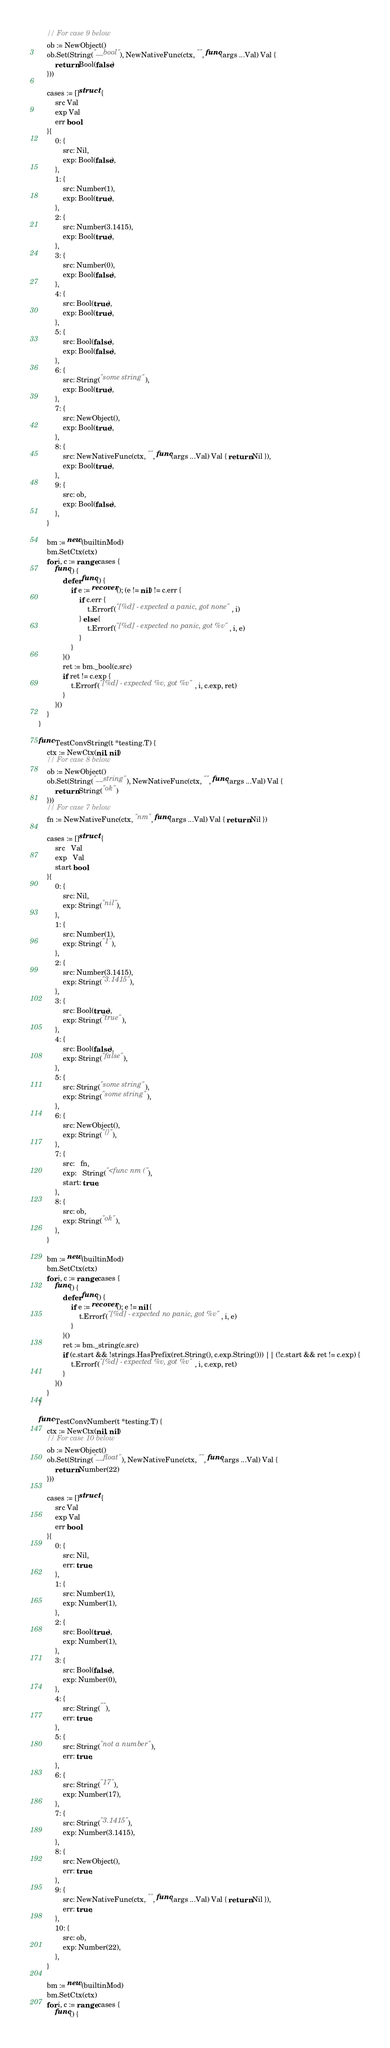Convert code to text. <code><loc_0><loc_0><loc_500><loc_500><_Go_>	// For case 9 below
	ob := NewObject()
	ob.Set(String("__bool"), NewNativeFunc(ctx, "", func(args ...Val) Val {
		return Bool(false)
	}))

	cases := []struct {
		src Val
		exp Val
		err bool
	}{
		0: {
			src: Nil,
			exp: Bool(false),
		},
		1: {
			src: Number(1),
			exp: Bool(true),
		},
		2: {
			src: Number(3.1415),
			exp: Bool(true),
		},
		3: {
			src: Number(0),
			exp: Bool(false),
		},
		4: {
			src: Bool(true),
			exp: Bool(true),
		},
		5: {
			src: Bool(false),
			exp: Bool(false),
		},
		6: {
			src: String("some string"),
			exp: Bool(true),
		},
		7: {
			src: NewObject(),
			exp: Bool(true),
		},
		8: {
			src: NewNativeFunc(ctx, "", func(args ...Val) Val { return Nil }),
			exp: Bool(true),
		},
		9: {
			src: ob,
			exp: Bool(false),
		},
	}

	bm := new(builtinMod)
	bm.SetCtx(ctx)
	for i, c := range cases {
		func() {
			defer func() {
				if e := recover(); (e != nil) != c.err {
					if c.err {
						t.Errorf("[%d] - expected a panic, got none", i)
					} else {
						t.Errorf("[%d] - expected no panic, got %v", i, e)
					}
				}
			}()
			ret := bm._bool(c.src)
			if ret != c.exp {
				t.Errorf("[%d] - expected %v, got %v", i, c.exp, ret)
			}
		}()
	}
}

func TestConvString(t *testing.T) {
	ctx := NewCtx(nil, nil)
	// For case 8 below
	ob := NewObject()
	ob.Set(String("__string"), NewNativeFunc(ctx, "", func(args ...Val) Val {
		return String("ok")
	}))
	// For case 7 below
	fn := NewNativeFunc(ctx, "nm", func(args ...Val) Val { return Nil })

	cases := []struct {
		src   Val
		exp   Val
		start bool
	}{
		0: {
			src: Nil,
			exp: String("nil"),
		},
		1: {
			src: Number(1),
			exp: String("1"),
		},
		2: {
			src: Number(3.1415),
			exp: String("3.1415"),
		},
		3: {
			src: Bool(true),
			exp: String("true"),
		},
		4: {
			src: Bool(false),
			exp: String("false"),
		},
		5: {
			src: String("some string"),
			exp: String("some string"),
		},
		6: {
			src: NewObject(),
			exp: String("{}"),
		},
		7: {
			src:   fn,
			exp:   String("<func nm ("),
			start: true,
		},
		8: {
			src: ob,
			exp: String("ok"),
		},
	}

	bm := new(builtinMod)
	bm.SetCtx(ctx)
	for i, c := range cases {
		func() {
			defer func() {
				if e := recover(); e != nil {
					t.Errorf("[%d] - expected no panic, got %v", i, e)
				}
			}()
			ret := bm._string(c.src)
			if (c.start && !strings.HasPrefix(ret.String(), c.exp.String())) || (!c.start && ret != c.exp) {
				t.Errorf("[%d] - expected %v, got %v", i, c.exp, ret)
			}
		}()
	}
}

func TestConvNumber(t *testing.T) {
	ctx := NewCtx(nil, nil)
	// For case 10 below
	ob := NewObject()
	ob.Set(String("__float"), NewNativeFunc(ctx, "", func(args ...Val) Val {
		return Number(22)
	}))

	cases := []struct {
		src Val
		exp Val
		err bool
	}{
		0: {
			src: Nil,
			err: true,
		},
		1: {
			src: Number(1),
			exp: Number(1),
		},
		2: {
			src: Bool(true),
			exp: Number(1),
		},
		3: {
			src: Bool(false),
			exp: Number(0),
		},
		4: {
			src: String(""),
			err: true,
		},
		5: {
			src: String("not a number"),
			err: true,
		},
		6: {
			src: String("17"),
			exp: Number(17),
		},
		7: {
			src: String("3.1415"),
			exp: Number(3.1415),
		},
		8: {
			src: NewObject(),
			err: true,
		},
		9: {
			src: NewNativeFunc(ctx, "", func(args ...Val) Val { return Nil }),
			err: true,
		},
		10: {
			src: ob,
			exp: Number(22),
		},
	}

	bm := new(builtinMod)
	bm.SetCtx(ctx)
	for i, c := range cases {
		func() {</code> 